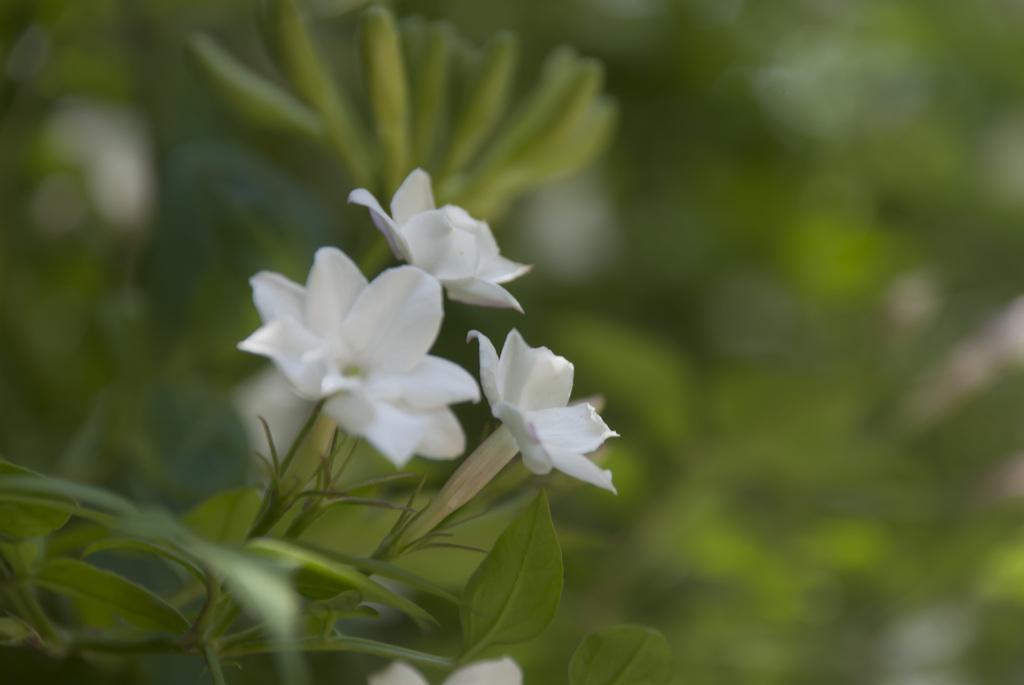In one or two sentences, can you explain what this image depicts? In this image I can see few flowers in white color, background I can see few plants in green color. 